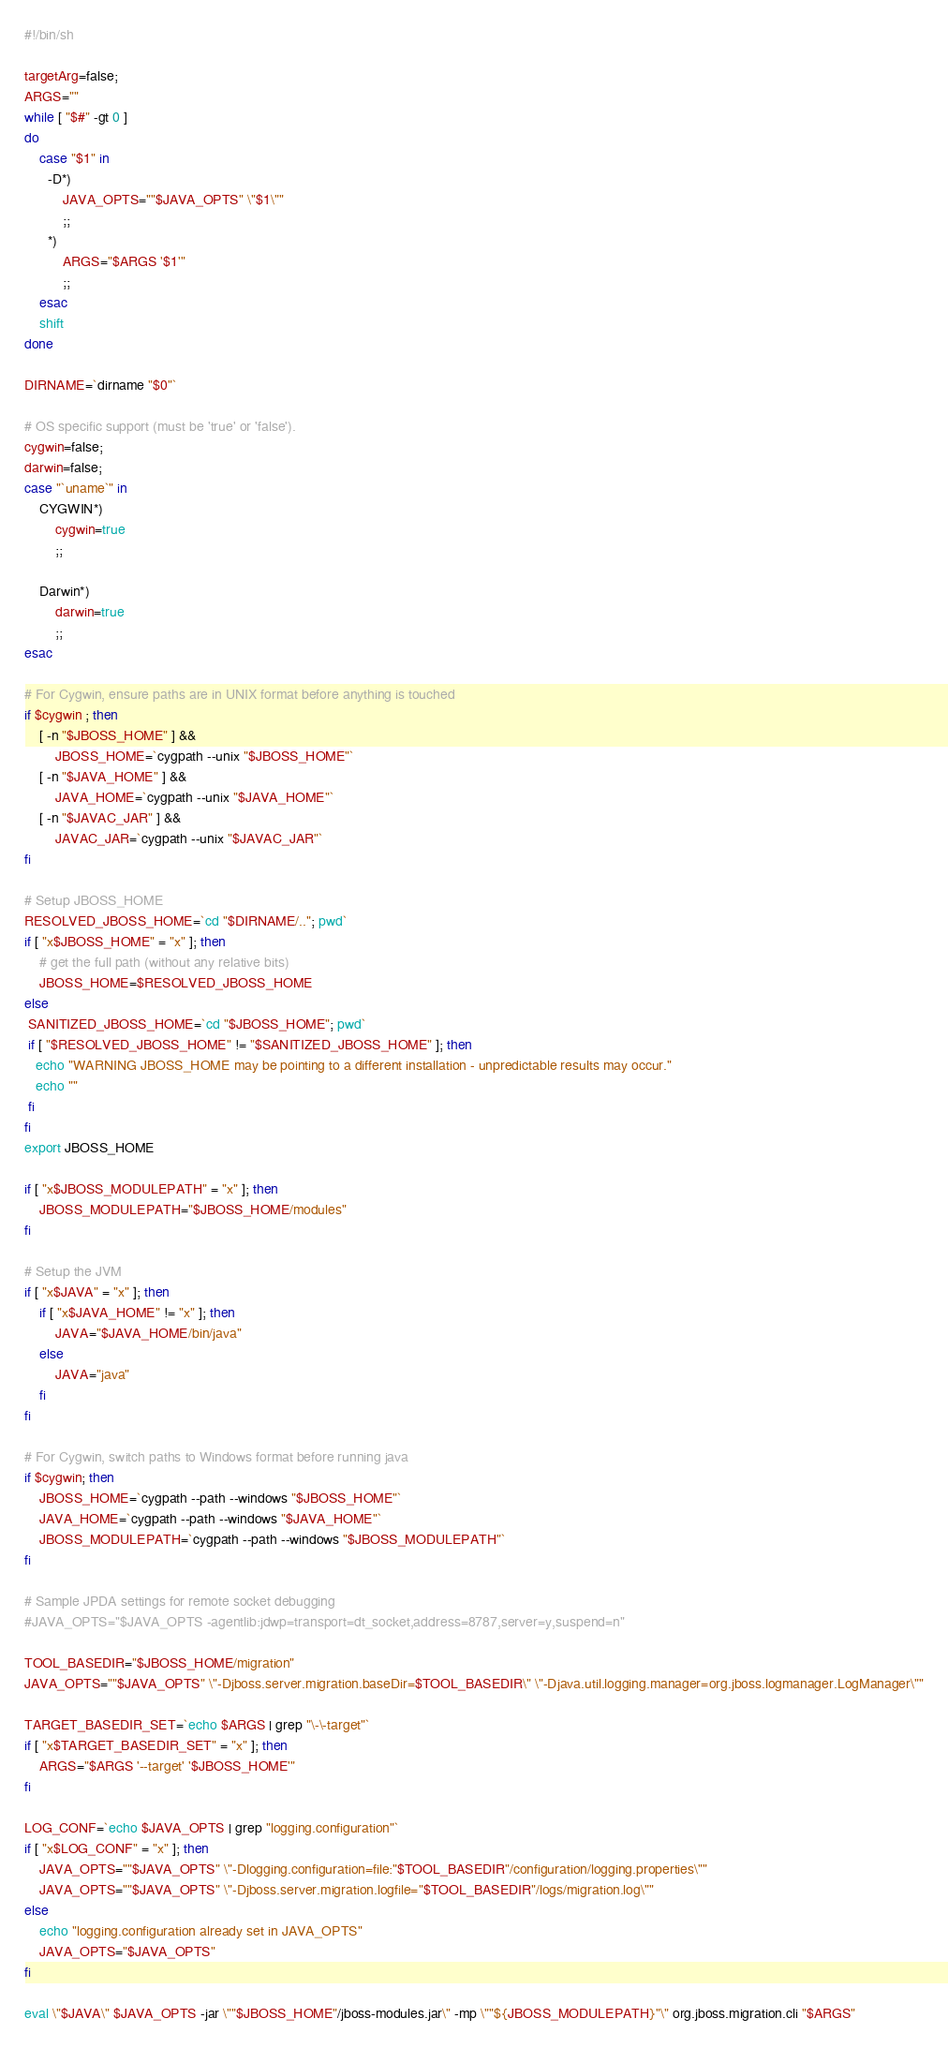Convert code to text. <code><loc_0><loc_0><loc_500><loc_500><_Bash_>#!/bin/sh

targetArg=false;
ARGS=""
while [ "$#" -gt 0 ]
do
    case "$1" in
      -D*)
          JAVA_OPTS=""$JAVA_OPTS" \"$1\""
          ;;
      *)
          ARGS="$ARGS '$1'"
          ;;
    esac
    shift
done

DIRNAME=`dirname "$0"`

# OS specific support (must be 'true' or 'false').
cygwin=false;
darwin=false;
case "`uname`" in
    CYGWIN*)
        cygwin=true
        ;;

    Darwin*)
        darwin=true
        ;;
esac

# For Cygwin, ensure paths are in UNIX format before anything is touched
if $cygwin ; then
    [ -n "$JBOSS_HOME" ] &&
        JBOSS_HOME=`cygpath --unix "$JBOSS_HOME"`
    [ -n "$JAVA_HOME" ] &&
        JAVA_HOME=`cygpath --unix "$JAVA_HOME"`
    [ -n "$JAVAC_JAR" ] &&
        JAVAC_JAR=`cygpath --unix "$JAVAC_JAR"`
fi

# Setup JBOSS_HOME
RESOLVED_JBOSS_HOME=`cd "$DIRNAME/.."; pwd`
if [ "x$JBOSS_HOME" = "x" ]; then
    # get the full path (without any relative bits)
    JBOSS_HOME=$RESOLVED_JBOSS_HOME
else
 SANITIZED_JBOSS_HOME=`cd "$JBOSS_HOME"; pwd`
 if [ "$RESOLVED_JBOSS_HOME" != "$SANITIZED_JBOSS_HOME" ]; then
   echo "WARNING JBOSS_HOME may be pointing to a different installation - unpredictable results may occur."
   echo ""
 fi
fi
export JBOSS_HOME

if [ "x$JBOSS_MODULEPATH" = "x" ]; then
    JBOSS_MODULEPATH="$JBOSS_HOME/modules"
fi

# Setup the JVM
if [ "x$JAVA" = "x" ]; then
    if [ "x$JAVA_HOME" != "x" ]; then
        JAVA="$JAVA_HOME/bin/java"
    else
        JAVA="java"
    fi
fi

# For Cygwin, switch paths to Windows format before running java
if $cygwin; then
    JBOSS_HOME=`cygpath --path --windows "$JBOSS_HOME"`
    JAVA_HOME=`cygpath --path --windows "$JAVA_HOME"`
    JBOSS_MODULEPATH=`cygpath --path --windows "$JBOSS_MODULEPATH"`
fi

# Sample JPDA settings for remote socket debugging
#JAVA_OPTS="$JAVA_OPTS -agentlib:jdwp=transport=dt_socket,address=8787,server=y,suspend=n"

TOOL_BASEDIR="$JBOSS_HOME/migration"
JAVA_OPTS=""$JAVA_OPTS" \"-Djboss.server.migration.baseDir=$TOOL_BASEDIR\" \"-Djava.util.logging.manager=org.jboss.logmanager.LogManager\""

TARGET_BASEDIR_SET=`echo $ARGS | grep "\-\-target"`
if [ "x$TARGET_BASEDIR_SET" = "x" ]; then
    ARGS="$ARGS '--target' '$JBOSS_HOME'"
fi

LOG_CONF=`echo $JAVA_OPTS | grep "logging.configuration"`
if [ "x$LOG_CONF" = "x" ]; then
    JAVA_OPTS=""$JAVA_OPTS" \"-Dlogging.configuration=file:"$TOOL_BASEDIR"/configuration/logging.properties\""
    JAVA_OPTS=""$JAVA_OPTS" \"-Djboss.server.migration.logfile="$TOOL_BASEDIR"/logs/migration.log\""
else
    echo "logging.configuration already set in JAVA_OPTS"
    JAVA_OPTS="$JAVA_OPTS"
fi

eval \"$JAVA\" $JAVA_OPTS -jar \""$JBOSS_HOME"/jboss-modules.jar\" -mp \""${JBOSS_MODULEPATH}"\" org.jboss.migration.cli "$ARGS"</code> 